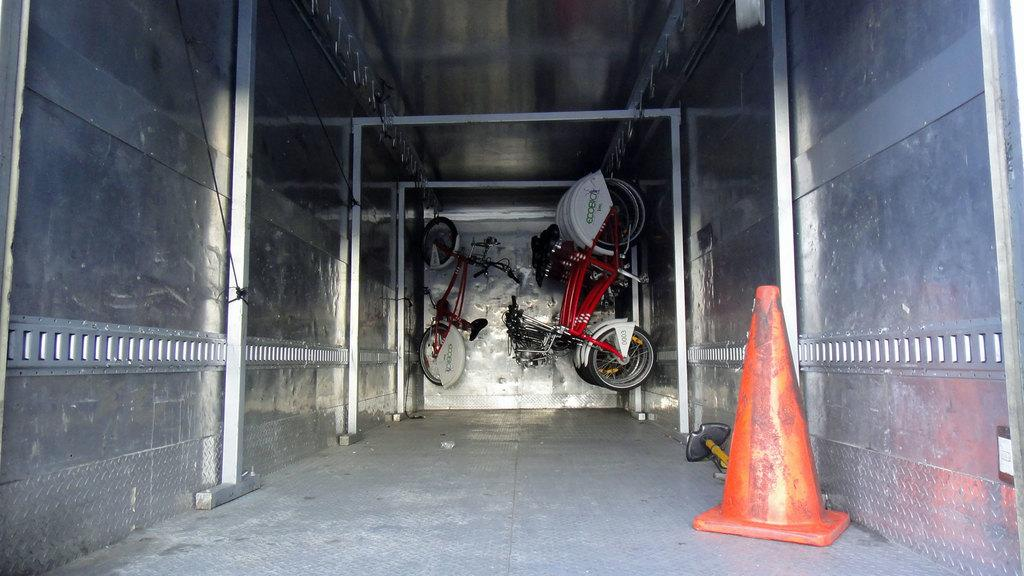What is hanging from the roof in the image? There are bicycles hanging from the roof in the image. What can be seen in the background of the image? There is a wall in the background of the image. What shape is present on the right side of the image? There is an inverted cone on the right side of the image. What is on the floor in the image? There are objects on the floor in the image. Can you see a loaf of bread on the bicycles in the image? There is no loaf of bread present on the bicycles in the image. Is there a tent visible in the image? There is no tent present in the image. 